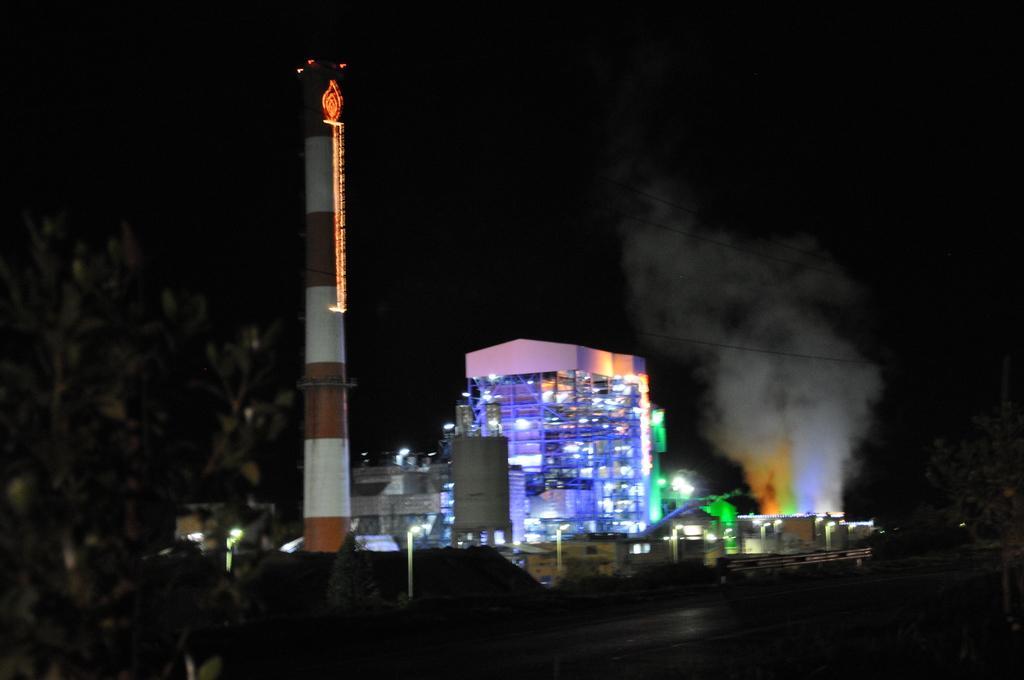Could you give a brief overview of what you see in this image? In this image I can see some buildings. On the left side I can see a tree. I can see the lights. 